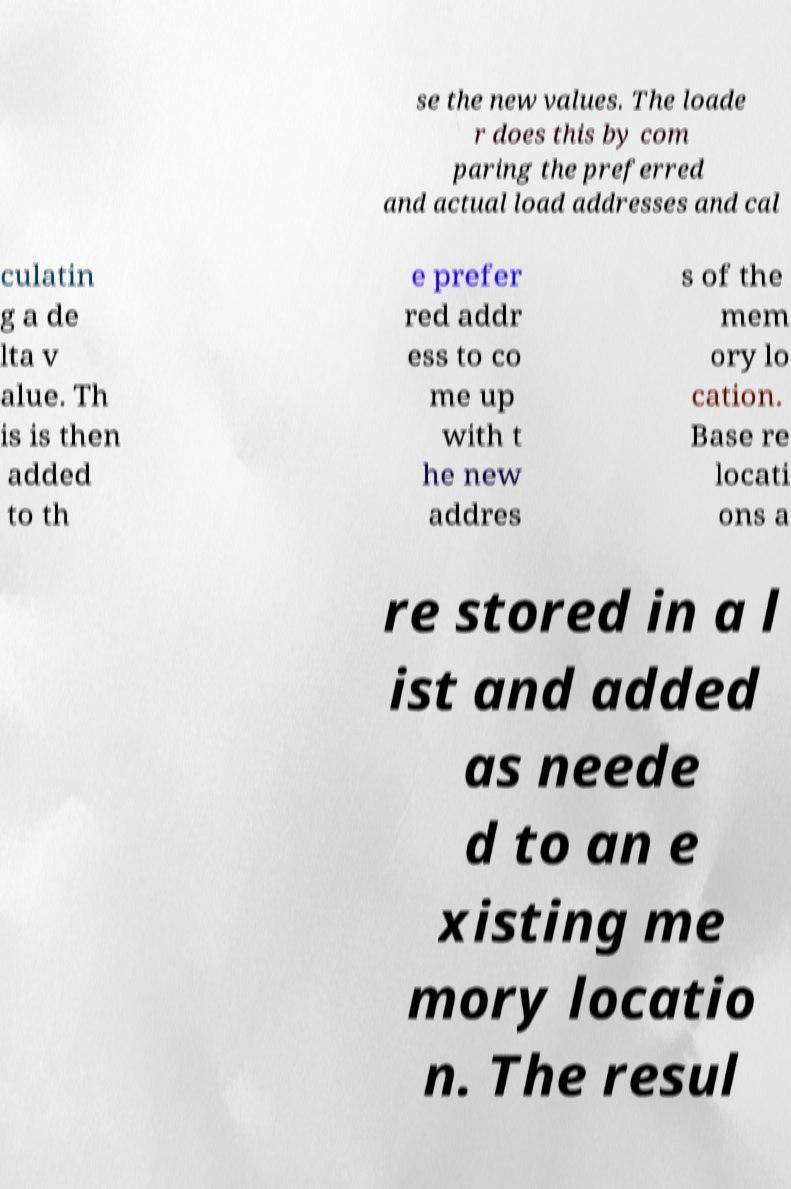For documentation purposes, I need the text within this image transcribed. Could you provide that? se the new values. The loade r does this by com paring the preferred and actual load addresses and cal culatin g a de lta v alue. Th is is then added to th e prefer red addr ess to co me up with t he new addres s of the mem ory lo cation. Base re locati ons a re stored in a l ist and added as neede d to an e xisting me mory locatio n. The resul 